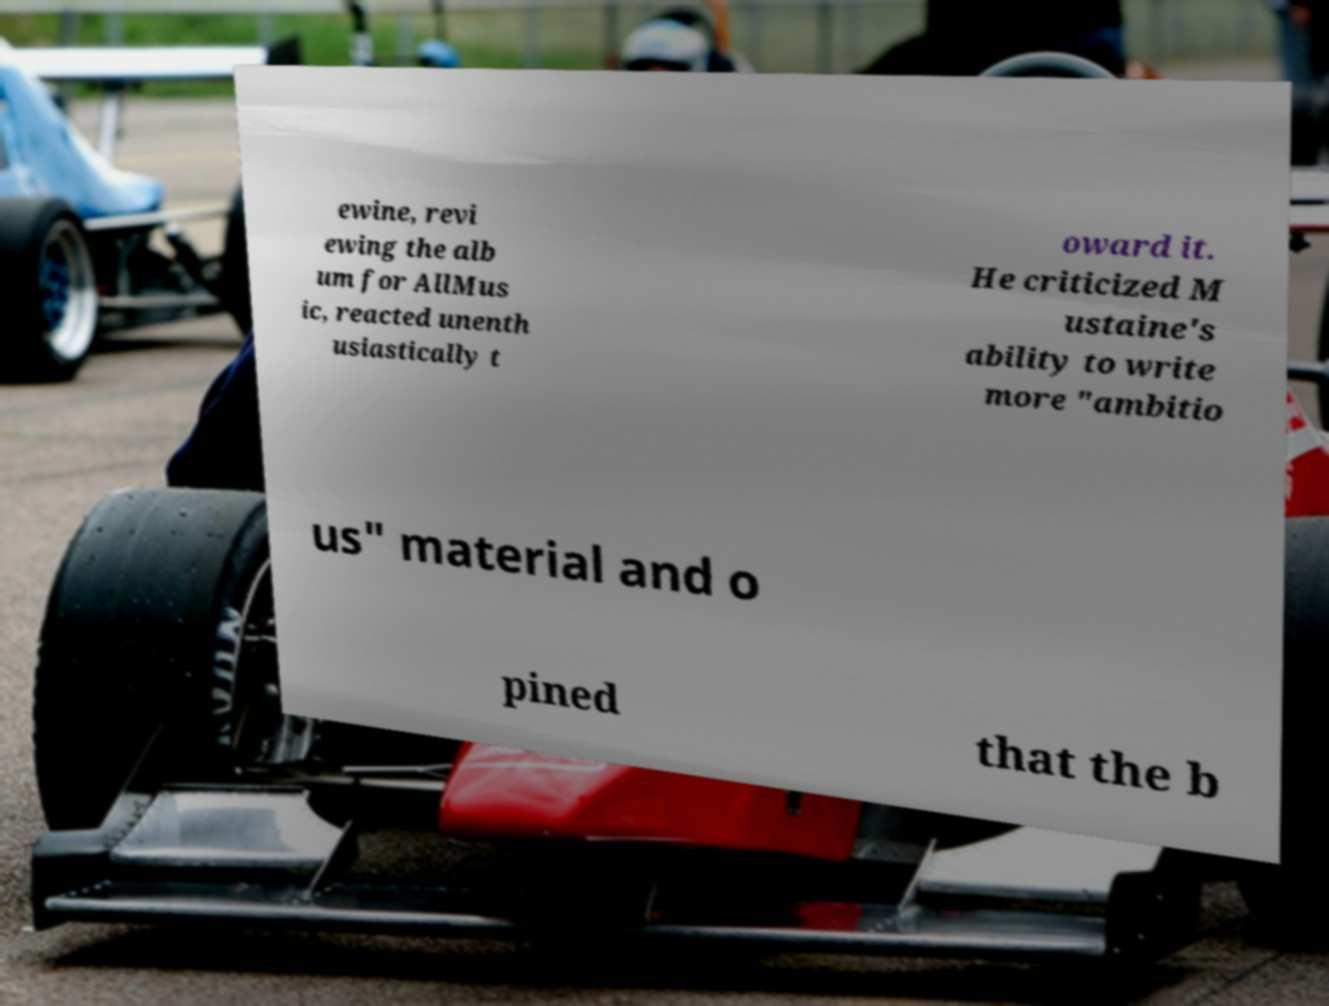Could you extract and type out the text from this image? ewine, revi ewing the alb um for AllMus ic, reacted unenth usiastically t oward it. He criticized M ustaine's ability to write more "ambitio us" material and o pined that the b 